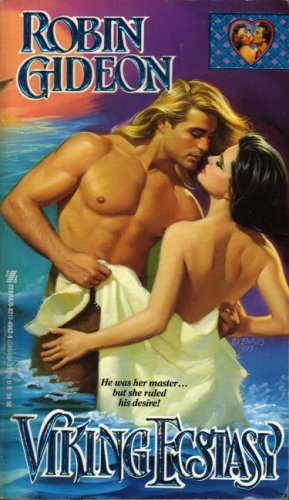Is this a romantic book? Yes, it is indeed a romantic book, clearly reflected in the intense and intimate interaction between characters depicted on the cover. 